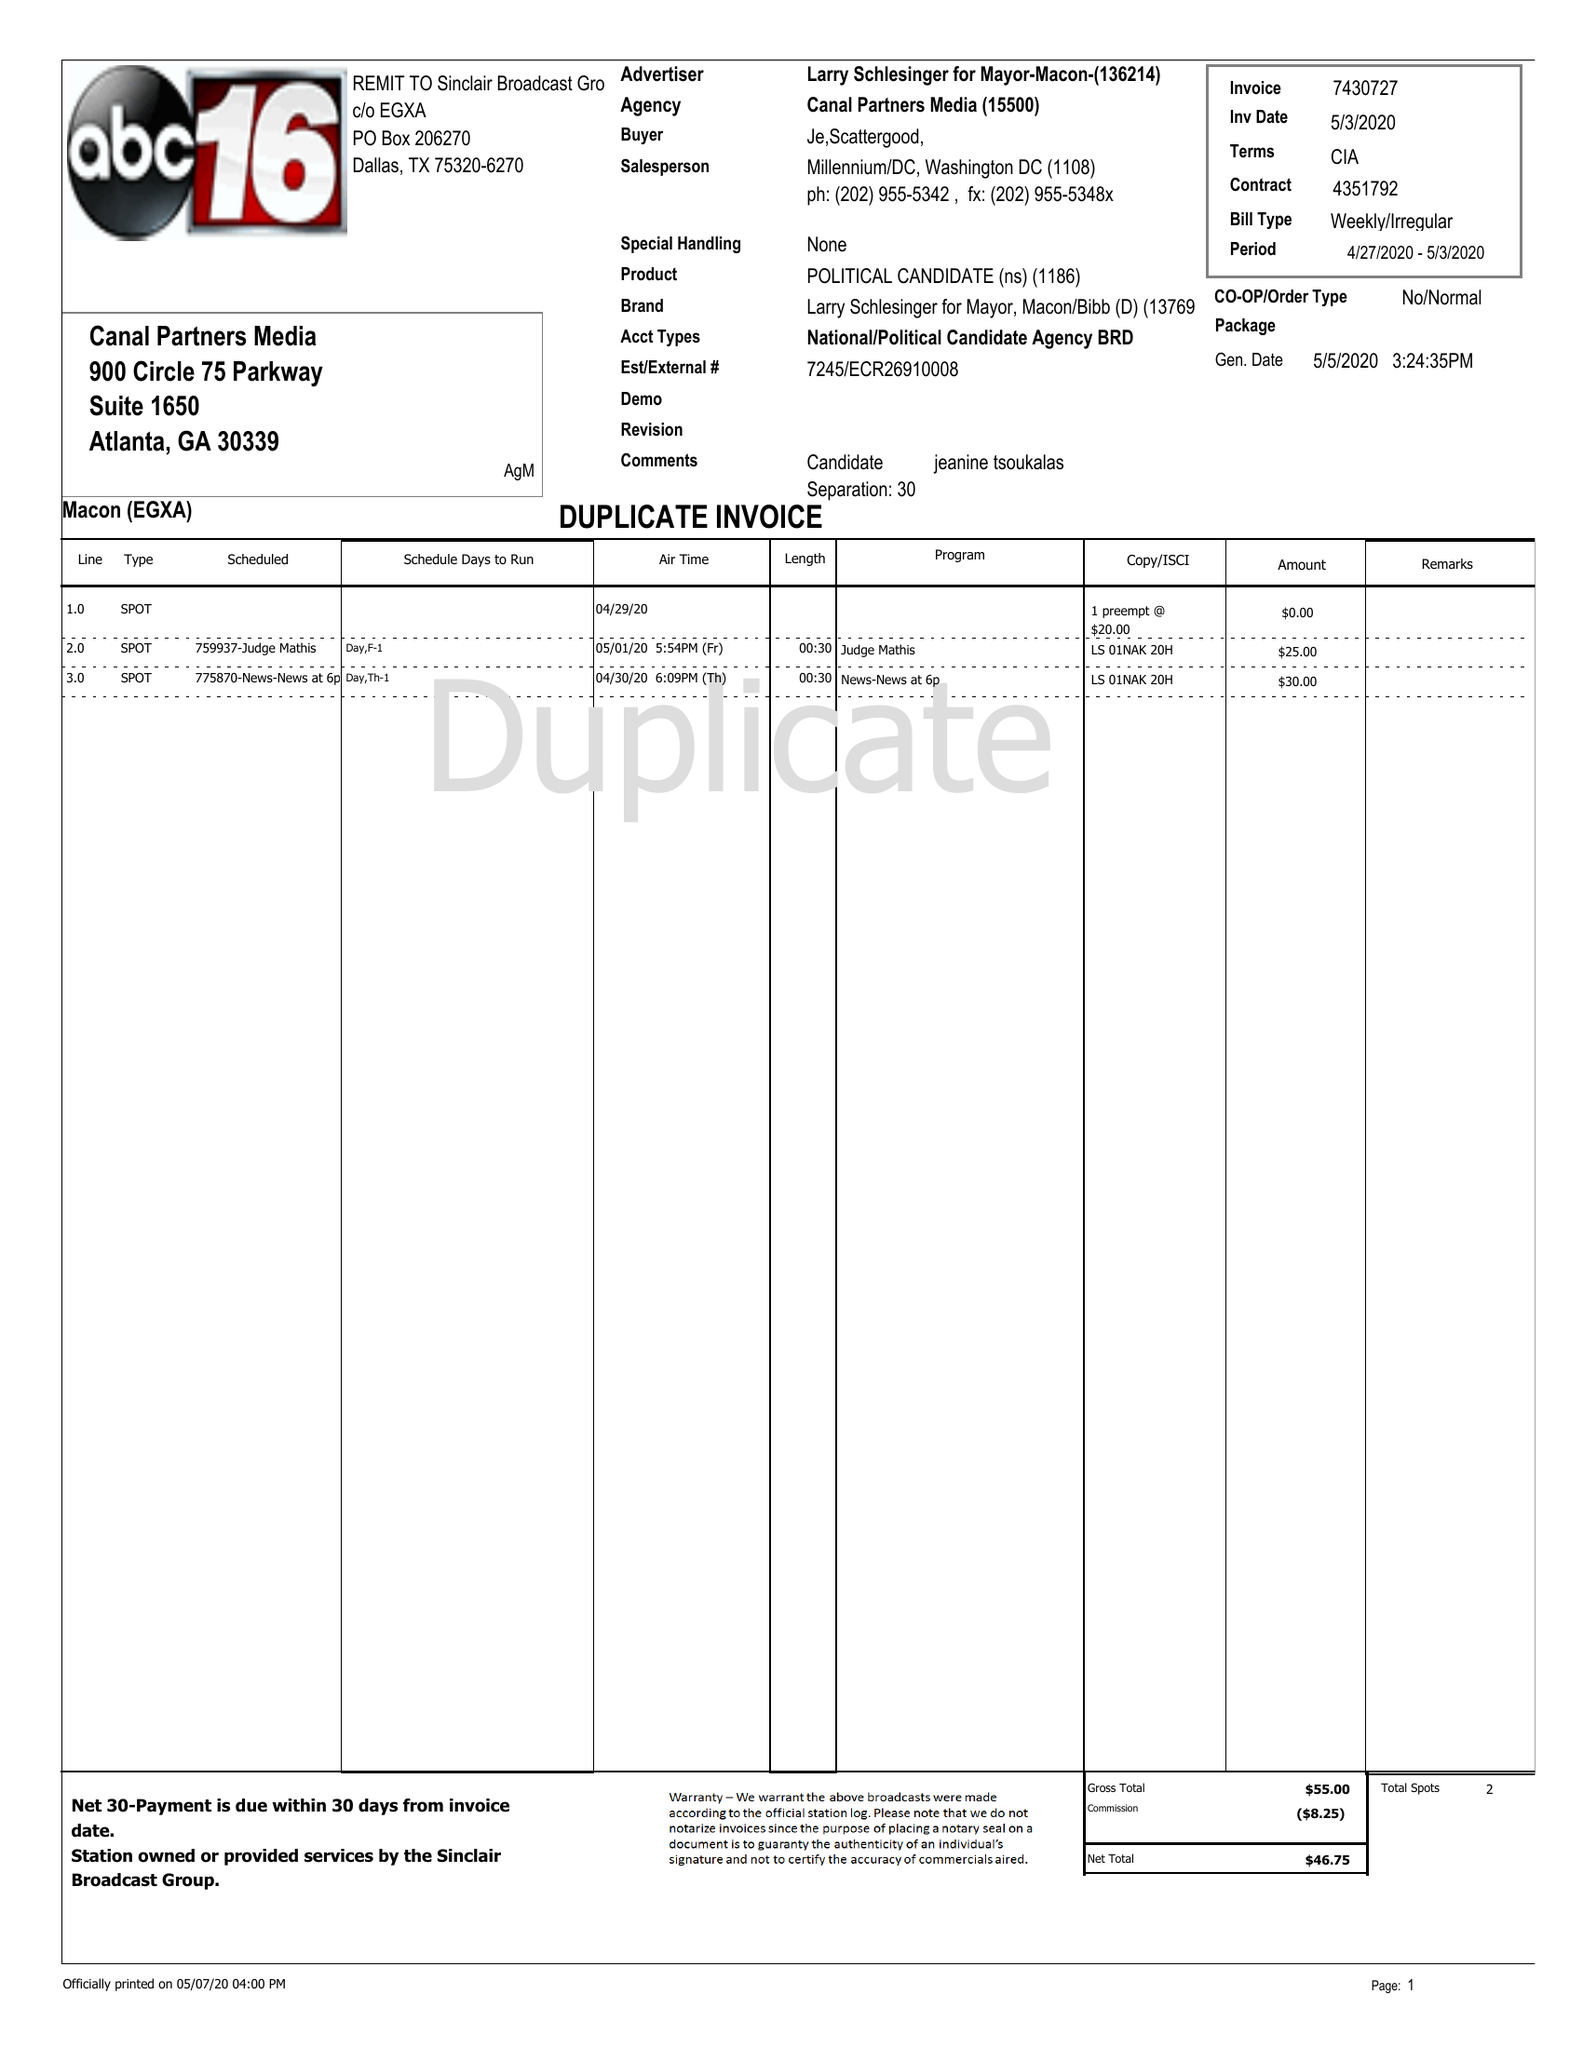What is the value for the flight_to?
Answer the question using a single word or phrase. 05/03/20 